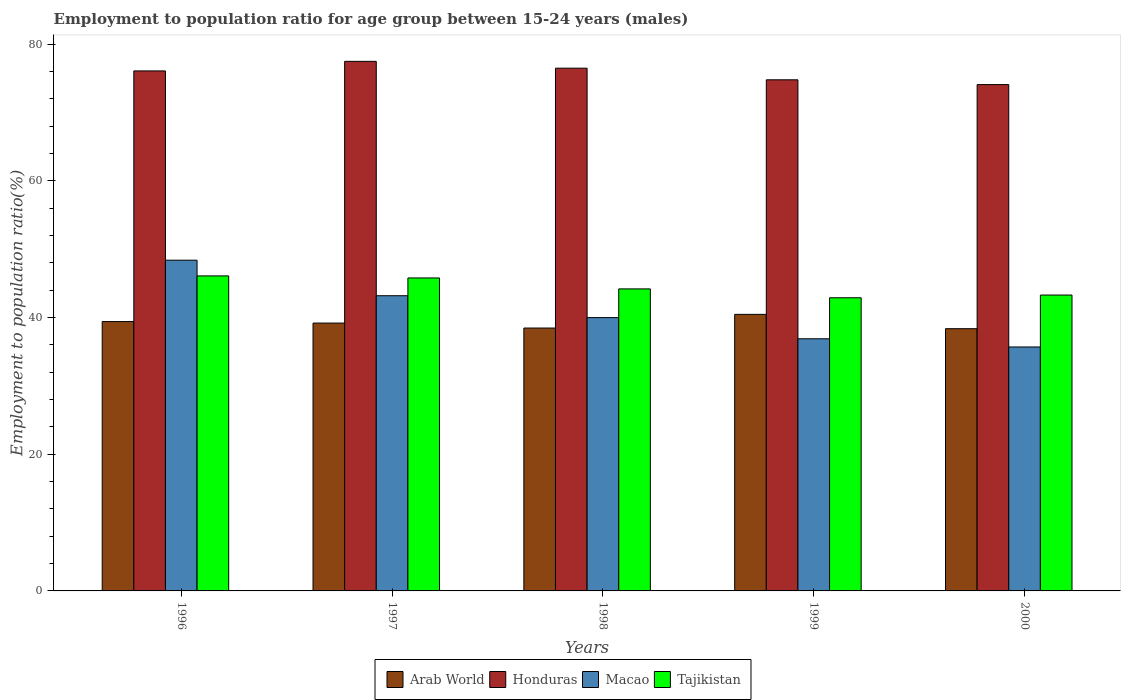Are the number of bars per tick equal to the number of legend labels?
Give a very brief answer. Yes. Are the number of bars on each tick of the X-axis equal?
Give a very brief answer. Yes. How many bars are there on the 5th tick from the left?
Provide a succinct answer. 4. What is the employment to population ratio in Honduras in 2000?
Ensure brevity in your answer.  74.1. Across all years, what is the maximum employment to population ratio in Arab World?
Your response must be concise. 40.47. Across all years, what is the minimum employment to population ratio in Honduras?
Provide a short and direct response. 74.1. In which year was the employment to population ratio in Honduras maximum?
Ensure brevity in your answer.  1997. What is the total employment to population ratio in Tajikistan in the graph?
Keep it short and to the point. 222.3. What is the difference between the employment to population ratio in Honduras in 1996 and that in 1998?
Your answer should be compact. -0.4. What is the difference between the employment to population ratio in Tajikistan in 2000 and the employment to population ratio in Arab World in 1997?
Provide a short and direct response. 4.1. What is the average employment to population ratio in Arab World per year?
Your answer should be compact. 39.19. In the year 1996, what is the difference between the employment to population ratio in Honduras and employment to population ratio in Tajikistan?
Offer a terse response. 30. What is the ratio of the employment to population ratio in Tajikistan in 1996 to that in 1998?
Your answer should be compact. 1.04. What is the difference between the highest and the second highest employment to population ratio in Tajikistan?
Make the answer very short. 0.3. What is the difference between the highest and the lowest employment to population ratio in Macao?
Keep it short and to the point. 12.7. What does the 4th bar from the left in 1997 represents?
Your answer should be very brief. Tajikistan. What does the 3rd bar from the right in 1998 represents?
Provide a succinct answer. Honduras. How many bars are there?
Your answer should be very brief. 20. What is the difference between two consecutive major ticks on the Y-axis?
Your response must be concise. 20. Are the values on the major ticks of Y-axis written in scientific E-notation?
Ensure brevity in your answer.  No. Does the graph contain any zero values?
Give a very brief answer. No. Does the graph contain grids?
Keep it short and to the point. No. Where does the legend appear in the graph?
Ensure brevity in your answer.  Bottom center. How are the legend labels stacked?
Your answer should be compact. Horizontal. What is the title of the graph?
Provide a short and direct response. Employment to population ratio for age group between 15-24 years (males). What is the label or title of the X-axis?
Your answer should be compact. Years. What is the label or title of the Y-axis?
Provide a short and direct response. Employment to population ratio(%). What is the Employment to population ratio(%) of Arab World in 1996?
Your answer should be compact. 39.42. What is the Employment to population ratio(%) of Honduras in 1996?
Ensure brevity in your answer.  76.1. What is the Employment to population ratio(%) of Macao in 1996?
Your response must be concise. 48.4. What is the Employment to population ratio(%) in Tajikistan in 1996?
Keep it short and to the point. 46.1. What is the Employment to population ratio(%) in Arab World in 1997?
Provide a short and direct response. 39.2. What is the Employment to population ratio(%) in Honduras in 1997?
Your answer should be compact. 77.5. What is the Employment to population ratio(%) of Macao in 1997?
Offer a terse response. 43.2. What is the Employment to population ratio(%) in Tajikistan in 1997?
Ensure brevity in your answer.  45.8. What is the Employment to population ratio(%) of Arab World in 1998?
Your response must be concise. 38.47. What is the Employment to population ratio(%) in Honduras in 1998?
Your response must be concise. 76.5. What is the Employment to population ratio(%) of Tajikistan in 1998?
Make the answer very short. 44.2. What is the Employment to population ratio(%) in Arab World in 1999?
Make the answer very short. 40.47. What is the Employment to population ratio(%) in Honduras in 1999?
Offer a terse response. 74.8. What is the Employment to population ratio(%) of Macao in 1999?
Offer a very short reply. 36.9. What is the Employment to population ratio(%) in Tajikistan in 1999?
Your answer should be very brief. 42.9. What is the Employment to population ratio(%) of Arab World in 2000?
Offer a terse response. 38.38. What is the Employment to population ratio(%) in Honduras in 2000?
Keep it short and to the point. 74.1. What is the Employment to population ratio(%) of Macao in 2000?
Keep it short and to the point. 35.7. What is the Employment to population ratio(%) of Tajikistan in 2000?
Provide a succinct answer. 43.3. Across all years, what is the maximum Employment to population ratio(%) in Arab World?
Ensure brevity in your answer.  40.47. Across all years, what is the maximum Employment to population ratio(%) of Honduras?
Give a very brief answer. 77.5. Across all years, what is the maximum Employment to population ratio(%) in Macao?
Provide a succinct answer. 48.4. Across all years, what is the maximum Employment to population ratio(%) of Tajikistan?
Ensure brevity in your answer.  46.1. Across all years, what is the minimum Employment to population ratio(%) of Arab World?
Provide a short and direct response. 38.38. Across all years, what is the minimum Employment to population ratio(%) of Honduras?
Your answer should be very brief. 74.1. Across all years, what is the minimum Employment to population ratio(%) of Macao?
Offer a very short reply. 35.7. Across all years, what is the minimum Employment to population ratio(%) in Tajikistan?
Provide a short and direct response. 42.9. What is the total Employment to population ratio(%) of Arab World in the graph?
Ensure brevity in your answer.  195.94. What is the total Employment to population ratio(%) in Honduras in the graph?
Ensure brevity in your answer.  379. What is the total Employment to population ratio(%) in Macao in the graph?
Offer a terse response. 204.2. What is the total Employment to population ratio(%) in Tajikistan in the graph?
Ensure brevity in your answer.  222.3. What is the difference between the Employment to population ratio(%) in Arab World in 1996 and that in 1997?
Your answer should be compact. 0.22. What is the difference between the Employment to population ratio(%) in Macao in 1996 and that in 1997?
Offer a terse response. 5.2. What is the difference between the Employment to population ratio(%) in Macao in 1996 and that in 1998?
Your answer should be very brief. 8.4. What is the difference between the Employment to population ratio(%) in Arab World in 1996 and that in 1999?
Ensure brevity in your answer.  -1.05. What is the difference between the Employment to population ratio(%) in Honduras in 1996 and that in 1999?
Ensure brevity in your answer.  1.3. What is the difference between the Employment to population ratio(%) in Arab World in 1996 and that in 2000?
Ensure brevity in your answer.  1.04. What is the difference between the Employment to population ratio(%) of Honduras in 1996 and that in 2000?
Give a very brief answer. 2. What is the difference between the Employment to population ratio(%) of Arab World in 1997 and that in 1998?
Your response must be concise. 0.73. What is the difference between the Employment to population ratio(%) in Tajikistan in 1997 and that in 1998?
Keep it short and to the point. 1.6. What is the difference between the Employment to population ratio(%) of Arab World in 1997 and that in 1999?
Give a very brief answer. -1.27. What is the difference between the Employment to population ratio(%) in Honduras in 1997 and that in 1999?
Your answer should be very brief. 2.7. What is the difference between the Employment to population ratio(%) of Tajikistan in 1997 and that in 1999?
Provide a succinct answer. 2.9. What is the difference between the Employment to population ratio(%) of Arab World in 1997 and that in 2000?
Make the answer very short. 0.82. What is the difference between the Employment to population ratio(%) of Honduras in 1997 and that in 2000?
Ensure brevity in your answer.  3.4. What is the difference between the Employment to population ratio(%) of Macao in 1997 and that in 2000?
Offer a very short reply. 7.5. What is the difference between the Employment to population ratio(%) in Arab World in 1998 and that in 1999?
Give a very brief answer. -2. What is the difference between the Employment to population ratio(%) in Honduras in 1998 and that in 1999?
Your answer should be very brief. 1.7. What is the difference between the Employment to population ratio(%) in Tajikistan in 1998 and that in 1999?
Provide a succinct answer. 1.3. What is the difference between the Employment to population ratio(%) of Arab World in 1998 and that in 2000?
Your response must be concise. 0.1. What is the difference between the Employment to population ratio(%) of Tajikistan in 1998 and that in 2000?
Keep it short and to the point. 0.9. What is the difference between the Employment to population ratio(%) of Arab World in 1999 and that in 2000?
Your response must be concise. 2.1. What is the difference between the Employment to population ratio(%) in Arab World in 1996 and the Employment to population ratio(%) in Honduras in 1997?
Your answer should be very brief. -38.08. What is the difference between the Employment to population ratio(%) of Arab World in 1996 and the Employment to population ratio(%) of Macao in 1997?
Provide a succinct answer. -3.78. What is the difference between the Employment to population ratio(%) of Arab World in 1996 and the Employment to population ratio(%) of Tajikistan in 1997?
Provide a short and direct response. -6.38. What is the difference between the Employment to population ratio(%) in Honduras in 1996 and the Employment to population ratio(%) in Macao in 1997?
Provide a short and direct response. 32.9. What is the difference between the Employment to population ratio(%) in Honduras in 1996 and the Employment to population ratio(%) in Tajikistan in 1997?
Make the answer very short. 30.3. What is the difference between the Employment to population ratio(%) in Arab World in 1996 and the Employment to population ratio(%) in Honduras in 1998?
Your answer should be compact. -37.08. What is the difference between the Employment to population ratio(%) of Arab World in 1996 and the Employment to population ratio(%) of Macao in 1998?
Your response must be concise. -0.58. What is the difference between the Employment to population ratio(%) of Arab World in 1996 and the Employment to population ratio(%) of Tajikistan in 1998?
Give a very brief answer. -4.78. What is the difference between the Employment to population ratio(%) in Honduras in 1996 and the Employment to population ratio(%) in Macao in 1998?
Make the answer very short. 36.1. What is the difference between the Employment to population ratio(%) of Honduras in 1996 and the Employment to population ratio(%) of Tajikistan in 1998?
Your response must be concise. 31.9. What is the difference between the Employment to population ratio(%) of Macao in 1996 and the Employment to population ratio(%) of Tajikistan in 1998?
Provide a succinct answer. 4.2. What is the difference between the Employment to population ratio(%) in Arab World in 1996 and the Employment to population ratio(%) in Honduras in 1999?
Provide a succinct answer. -35.38. What is the difference between the Employment to population ratio(%) of Arab World in 1996 and the Employment to population ratio(%) of Macao in 1999?
Your answer should be very brief. 2.52. What is the difference between the Employment to population ratio(%) of Arab World in 1996 and the Employment to population ratio(%) of Tajikistan in 1999?
Provide a succinct answer. -3.48. What is the difference between the Employment to population ratio(%) of Honduras in 1996 and the Employment to population ratio(%) of Macao in 1999?
Your answer should be compact. 39.2. What is the difference between the Employment to population ratio(%) in Honduras in 1996 and the Employment to population ratio(%) in Tajikistan in 1999?
Offer a terse response. 33.2. What is the difference between the Employment to population ratio(%) in Macao in 1996 and the Employment to population ratio(%) in Tajikistan in 1999?
Provide a short and direct response. 5.5. What is the difference between the Employment to population ratio(%) of Arab World in 1996 and the Employment to population ratio(%) of Honduras in 2000?
Your answer should be very brief. -34.68. What is the difference between the Employment to population ratio(%) of Arab World in 1996 and the Employment to population ratio(%) of Macao in 2000?
Offer a very short reply. 3.72. What is the difference between the Employment to population ratio(%) in Arab World in 1996 and the Employment to population ratio(%) in Tajikistan in 2000?
Provide a succinct answer. -3.88. What is the difference between the Employment to population ratio(%) in Honduras in 1996 and the Employment to population ratio(%) in Macao in 2000?
Provide a succinct answer. 40.4. What is the difference between the Employment to population ratio(%) of Honduras in 1996 and the Employment to population ratio(%) of Tajikistan in 2000?
Provide a short and direct response. 32.8. What is the difference between the Employment to population ratio(%) in Arab World in 1997 and the Employment to population ratio(%) in Honduras in 1998?
Provide a short and direct response. -37.3. What is the difference between the Employment to population ratio(%) of Arab World in 1997 and the Employment to population ratio(%) of Macao in 1998?
Make the answer very short. -0.8. What is the difference between the Employment to population ratio(%) of Arab World in 1997 and the Employment to population ratio(%) of Tajikistan in 1998?
Provide a short and direct response. -5. What is the difference between the Employment to population ratio(%) in Honduras in 1997 and the Employment to population ratio(%) in Macao in 1998?
Keep it short and to the point. 37.5. What is the difference between the Employment to population ratio(%) of Honduras in 1997 and the Employment to population ratio(%) of Tajikistan in 1998?
Offer a terse response. 33.3. What is the difference between the Employment to population ratio(%) of Macao in 1997 and the Employment to population ratio(%) of Tajikistan in 1998?
Make the answer very short. -1. What is the difference between the Employment to population ratio(%) of Arab World in 1997 and the Employment to population ratio(%) of Honduras in 1999?
Ensure brevity in your answer.  -35.6. What is the difference between the Employment to population ratio(%) of Arab World in 1997 and the Employment to population ratio(%) of Macao in 1999?
Offer a terse response. 2.3. What is the difference between the Employment to population ratio(%) in Arab World in 1997 and the Employment to population ratio(%) in Tajikistan in 1999?
Keep it short and to the point. -3.7. What is the difference between the Employment to population ratio(%) in Honduras in 1997 and the Employment to population ratio(%) in Macao in 1999?
Offer a terse response. 40.6. What is the difference between the Employment to population ratio(%) of Honduras in 1997 and the Employment to population ratio(%) of Tajikistan in 1999?
Your answer should be very brief. 34.6. What is the difference between the Employment to population ratio(%) of Arab World in 1997 and the Employment to population ratio(%) of Honduras in 2000?
Provide a succinct answer. -34.9. What is the difference between the Employment to population ratio(%) of Arab World in 1997 and the Employment to population ratio(%) of Macao in 2000?
Your response must be concise. 3.5. What is the difference between the Employment to population ratio(%) in Arab World in 1997 and the Employment to population ratio(%) in Tajikistan in 2000?
Offer a very short reply. -4.1. What is the difference between the Employment to population ratio(%) in Honduras in 1997 and the Employment to population ratio(%) in Macao in 2000?
Ensure brevity in your answer.  41.8. What is the difference between the Employment to population ratio(%) of Honduras in 1997 and the Employment to population ratio(%) of Tajikistan in 2000?
Provide a succinct answer. 34.2. What is the difference between the Employment to population ratio(%) in Macao in 1997 and the Employment to population ratio(%) in Tajikistan in 2000?
Make the answer very short. -0.1. What is the difference between the Employment to population ratio(%) of Arab World in 1998 and the Employment to population ratio(%) of Honduras in 1999?
Your response must be concise. -36.33. What is the difference between the Employment to population ratio(%) of Arab World in 1998 and the Employment to population ratio(%) of Macao in 1999?
Give a very brief answer. 1.57. What is the difference between the Employment to population ratio(%) in Arab World in 1998 and the Employment to population ratio(%) in Tajikistan in 1999?
Keep it short and to the point. -4.43. What is the difference between the Employment to population ratio(%) in Honduras in 1998 and the Employment to population ratio(%) in Macao in 1999?
Provide a succinct answer. 39.6. What is the difference between the Employment to population ratio(%) in Honduras in 1998 and the Employment to population ratio(%) in Tajikistan in 1999?
Your answer should be very brief. 33.6. What is the difference between the Employment to population ratio(%) in Macao in 1998 and the Employment to population ratio(%) in Tajikistan in 1999?
Make the answer very short. -2.9. What is the difference between the Employment to population ratio(%) in Arab World in 1998 and the Employment to population ratio(%) in Honduras in 2000?
Give a very brief answer. -35.63. What is the difference between the Employment to population ratio(%) in Arab World in 1998 and the Employment to population ratio(%) in Macao in 2000?
Offer a very short reply. 2.77. What is the difference between the Employment to population ratio(%) in Arab World in 1998 and the Employment to population ratio(%) in Tajikistan in 2000?
Provide a succinct answer. -4.83. What is the difference between the Employment to population ratio(%) in Honduras in 1998 and the Employment to population ratio(%) in Macao in 2000?
Make the answer very short. 40.8. What is the difference between the Employment to population ratio(%) of Honduras in 1998 and the Employment to population ratio(%) of Tajikistan in 2000?
Make the answer very short. 33.2. What is the difference between the Employment to population ratio(%) in Macao in 1998 and the Employment to population ratio(%) in Tajikistan in 2000?
Ensure brevity in your answer.  -3.3. What is the difference between the Employment to population ratio(%) in Arab World in 1999 and the Employment to population ratio(%) in Honduras in 2000?
Give a very brief answer. -33.63. What is the difference between the Employment to population ratio(%) in Arab World in 1999 and the Employment to population ratio(%) in Macao in 2000?
Your answer should be very brief. 4.77. What is the difference between the Employment to population ratio(%) of Arab World in 1999 and the Employment to population ratio(%) of Tajikistan in 2000?
Give a very brief answer. -2.83. What is the difference between the Employment to population ratio(%) of Honduras in 1999 and the Employment to population ratio(%) of Macao in 2000?
Provide a short and direct response. 39.1. What is the difference between the Employment to population ratio(%) in Honduras in 1999 and the Employment to population ratio(%) in Tajikistan in 2000?
Offer a terse response. 31.5. What is the average Employment to population ratio(%) of Arab World per year?
Your answer should be very brief. 39.19. What is the average Employment to population ratio(%) of Honduras per year?
Provide a succinct answer. 75.8. What is the average Employment to population ratio(%) in Macao per year?
Make the answer very short. 40.84. What is the average Employment to population ratio(%) in Tajikistan per year?
Provide a short and direct response. 44.46. In the year 1996, what is the difference between the Employment to population ratio(%) in Arab World and Employment to population ratio(%) in Honduras?
Your response must be concise. -36.68. In the year 1996, what is the difference between the Employment to population ratio(%) of Arab World and Employment to population ratio(%) of Macao?
Ensure brevity in your answer.  -8.98. In the year 1996, what is the difference between the Employment to population ratio(%) of Arab World and Employment to population ratio(%) of Tajikistan?
Provide a short and direct response. -6.68. In the year 1996, what is the difference between the Employment to population ratio(%) of Honduras and Employment to population ratio(%) of Macao?
Offer a very short reply. 27.7. In the year 1997, what is the difference between the Employment to population ratio(%) of Arab World and Employment to population ratio(%) of Honduras?
Offer a terse response. -38.3. In the year 1997, what is the difference between the Employment to population ratio(%) of Arab World and Employment to population ratio(%) of Macao?
Provide a succinct answer. -4. In the year 1997, what is the difference between the Employment to population ratio(%) in Arab World and Employment to population ratio(%) in Tajikistan?
Your answer should be compact. -6.6. In the year 1997, what is the difference between the Employment to population ratio(%) in Honduras and Employment to population ratio(%) in Macao?
Offer a very short reply. 34.3. In the year 1997, what is the difference between the Employment to population ratio(%) of Honduras and Employment to population ratio(%) of Tajikistan?
Your answer should be very brief. 31.7. In the year 1997, what is the difference between the Employment to population ratio(%) of Macao and Employment to population ratio(%) of Tajikistan?
Give a very brief answer. -2.6. In the year 1998, what is the difference between the Employment to population ratio(%) of Arab World and Employment to population ratio(%) of Honduras?
Keep it short and to the point. -38.03. In the year 1998, what is the difference between the Employment to population ratio(%) in Arab World and Employment to population ratio(%) in Macao?
Provide a short and direct response. -1.53. In the year 1998, what is the difference between the Employment to population ratio(%) of Arab World and Employment to population ratio(%) of Tajikistan?
Your answer should be compact. -5.73. In the year 1998, what is the difference between the Employment to population ratio(%) of Honduras and Employment to population ratio(%) of Macao?
Provide a succinct answer. 36.5. In the year 1998, what is the difference between the Employment to population ratio(%) in Honduras and Employment to population ratio(%) in Tajikistan?
Your answer should be compact. 32.3. In the year 1998, what is the difference between the Employment to population ratio(%) of Macao and Employment to population ratio(%) of Tajikistan?
Ensure brevity in your answer.  -4.2. In the year 1999, what is the difference between the Employment to population ratio(%) in Arab World and Employment to population ratio(%) in Honduras?
Your answer should be compact. -34.33. In the year 1999, what is the difference between the Employment to population ratio(%) in Arab World and Employment to population ratio(%) in Macao?
Provide a short and direct response. 3.57. In the year 1999, what is the difference between the Employment to population ratio(%) in Arab World and Employment to population ratio(%) in Tajikistan?
Your answer should be compact. -2.43. In the year 1999, what is the difference between the Employment to population ratio(%) of Honduras and Employment to population ratio(%) of Macao?
Provide a short and direct response. 37.9. In the year 1999, what is the difference between the Employment to population ratio(%) in Honduras and Employment to population ratio(%) in Tajikistan?
Give a very brief answer. 31.9. In the year 2000, what is the difference between the Employment to population ratio(%) of Arab World and Employment to population ratio(%) of Honduras?
Offer a terse response. -35.72. In the year 2000, what is the difference between the Employment to population ratio(%) in Arab World and Employment to population ratio(%) in Macao?
Your answer should be compact. 2.68. In the year 2000, what is the difference between the Employment to population ratio(%) of Arab World and Employment to population ratio(%) of Tajikistan?
Your answer should be compact. -4.92. In the year 2000, what is the difference between the Employment to population ratio(%) in Honduras and Employment to population ratio(%) in Macao?
Your answer should be compact. 38.4. In the year 2000, what is the difference between the Employment to population ratio(%) of Honduras and Employment to population ratio(%) of Tajikistan?
Make the answer very short. 30.8. In the year 2000, what is the difference between the Employment to population ratio(%) in Macao and Employment to population ratio(%) in Tajikistan?
Offer a terse response. -7.6. What is the ratio of the Employment to population ratio(%) of Arab World in 1996 to that in 1997?
Offer a terse response. 1.01. What is the ratio of the Employment to population ratio(%) in Honduras in 1996 to that in 1997?
Provide a short and direct response. 0.98. What is the ratio of the Employment to population ratio(%) of Macao in 1996 to that in 1997?
Ensure brevity in your answer.  1.12. What is the ratio of the Employment to population ratio(%) in Tajikistan in 1996 to that in 1997?
Provide a short and direct response. 1.01. What is the ratio of the Employment to population ratio(%) in Arab World in 1996 to that in 1998?
Provide a short and direct response. 1.02. What is the ratio of the Employment to population ratio(%) in Macao in 1996 to that in 1998?
Your answer should be compact. 1.21. What is the ratio of the Employment to population ratio(%) in Tajikistan in 1996 to that in 1998?
Provide a short and direct response. 1.04. What is the ratio of the Employment to population ratio(%) in Honduras in 1996 to that in 1999?
Provide a short and direct response. 1.02. What is the ratio of the Employment to population ratio(%) in Macao in 1996 to that in 1999?
Make the answer very short. 1.31. What is the ratio of the Employment to population ratio(%) of Tajikistan in 1996 to that in 1999?
Your response must be concise. 1.07. What is the ratio of the Employment to population ratio(%) in Arab World in 1996 to that in 2000?
Your response must be concise. 1.03. What is the ratio of the Employment to population ratio(%) of Macao in 1996 to that in 2000?
Keep it short and to the point. 1.36. What is the ratio of the Employment to population ratio(%) in Tajikistan in 1996 to that in 2000?
Keep it short and to the point. 1.06. What is the ratio of the Employment to population ratio(%) in Arab World in 1997 to that in 1998?
Make the answer very short. 1.02. What is the ratio of the Employment to population ratio(%) in Honduras in 1997 to that in 1998?
Offer a very short reply. 1.01. What is the ratio of the Employment to population ratio(%) of Macao in 1997 to that in 1998?
Provide a short and direct response. 1.08. What is the ratio of the Employment to population ratio(%) of Tajikistan in 1997 to that in 1998?
Offer a terse response. 1.04. What is the ratio of the Employment to population ratio(%) of Arab World in 1997 to that in 1999?
Your answer should be compact. 0.97. What is the ratio of the Employment to population ratio(%) of Honduras in 1997 to that in 1999?
Your answer should be compact. 1.04. What is the ratio of the Employment to population ratio(%) in Macao in 1997 to that in 1999?
Provide a short and direct response. 1.17. What is the ratio of the Employment to population ratio(%) of Tajikistan in 1997 to that in 1999?
Offer a terse response. 1.07. What is the ratio of the Employment to population ratio(%) in Arab World in 1997 to that in 2000?
Make the answer very short. 1.02. What is the ratio of the Employment to population ratio(%) of Honduras in 1997 to that in 2000?
Give a very brief answer. 1.05. What is the ratio of the Employment to population ratio(%) of Macao in 1997 to that in 2000?
Give a very brief answer. 1.21. What is the ratio of the Employment to population ratio(%) in Tajikistan in 1997 to that in 2000?
Your answer should be compact. 1.06. What is the ratio of the Employment to population ratio(%) of Arab World in 1998 to that in 1999?
Offer a very short reply. 0.95. What is the ratio of the Employment to population ratio(%) in Honduras in 1998 to that in 1999?
Keep it short and to the point. 1.02. What is the ratio of the Employment to population ratio(%) in Macao in 1998 to that in 1999?
Give a very brief answer. 1.08. What is the ratio of the Employment to population ratio(%) in Tajikistan in 1998 to that in 1999?
Your answer should be compact. 1.03. What is the ratio of the Employment to population ratio(%) of Honduras in 1998 to that in 2000?
Provide a short and direct response. 1.03. What is the ratio of the Employment to population ratio(%) in Macao in 1998 to that in 2000?
Make the answer very short. 1.12. What is the ratio of the Employment to population ratio(%) in Tajikistan in 1998 to that in 2000?
Offer a very short reply. 1.02. What is the ratio of the Employment to population ratio(%) of Arab World in 1999 to that in 2000?
Your answer should be compact. 1.05. What is the ratio of the Employment to population ratio(%) in Honduras in 1999 to that in 2000?
Give a very brief answer. 1.01. What is the ratio of the Employment to population ratio(%) of Macao in 1999 to that in 2000?
Your answer should be very brief. 1.03. What is the ratio of the Employment to population ratio(%) of Tajikistan in 1999 to that in 2000?
Make the answer very short. 0.99. What is the difference between the highest and the second highest Employment to population ratio(%) of Arab World?
Offer a very short reply. 1.05. What is the difference between the highest and the second highest Employment to population ratio(%) of Macao?
Keep it short and to the point. 5.2. What is the difference between the highest and the second highest Employment to population ratio(%) in Tajikistan?
Your answer should be very brief. 0.3. What is the difference between the highest and the lowest Employment to population ratio(%) of Arab World?
Your answer should be compact. 2.1. What is the difference between the highest and the lowest Employment to population ratio(%) in Tajikistan?
Ensure brevity in your answer.  3.2. 